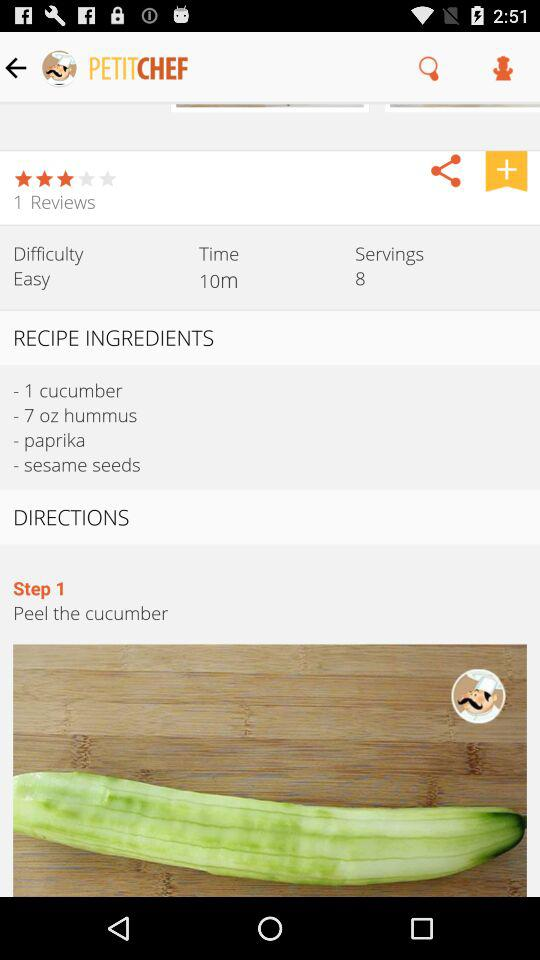What is the first step in "DIRECTIONS"? The first step is to peel the cucumber. 